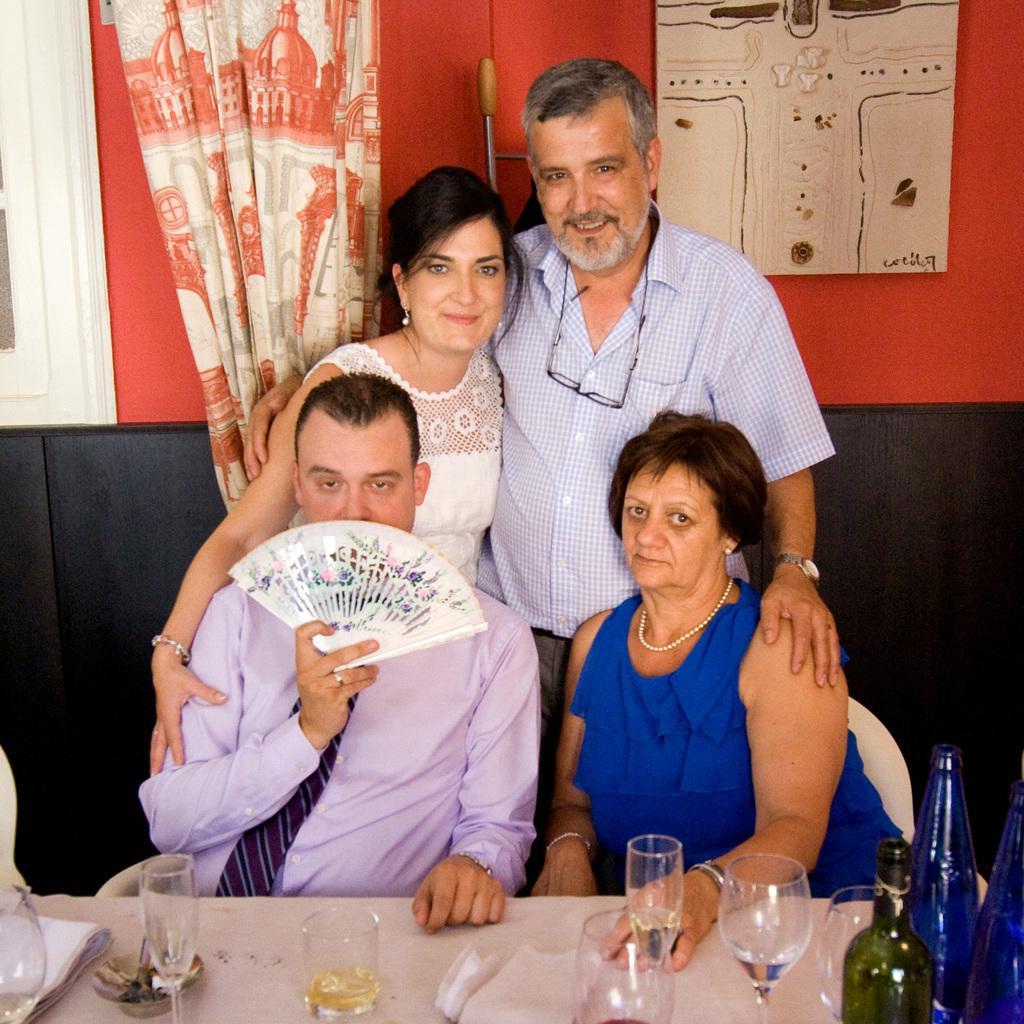Please provide a concise description of this image. In this picture we can see there are two people sitting on chairs and two people standing on the path. In front of the people there is a table and on the table there are glasses, bottles, tissues and a cloth. Behind the people there is a curtain and a wall with a photo frame, a window and an object. 